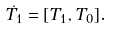Convert formula to latex. <formula><loc_0><loc_0><loc_500><loc_500>\dot { T _ { 1 } } = [ T _ { 1 } , T _ { 0 } ] .</formula> 